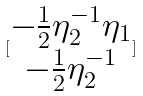Convert formula to latex. <formula><loc_0><loc_0><loc_500><loc_500>[ \begin{matrix} - \frac { 1 } { 2 } \eta _ { 2 } ^ { - 1 } \eta _ { 1 } \\ - \frac { 1 } { 2 } \eta _ { 2 } ^ { - 1 } \end{matrix} ]</formula> 